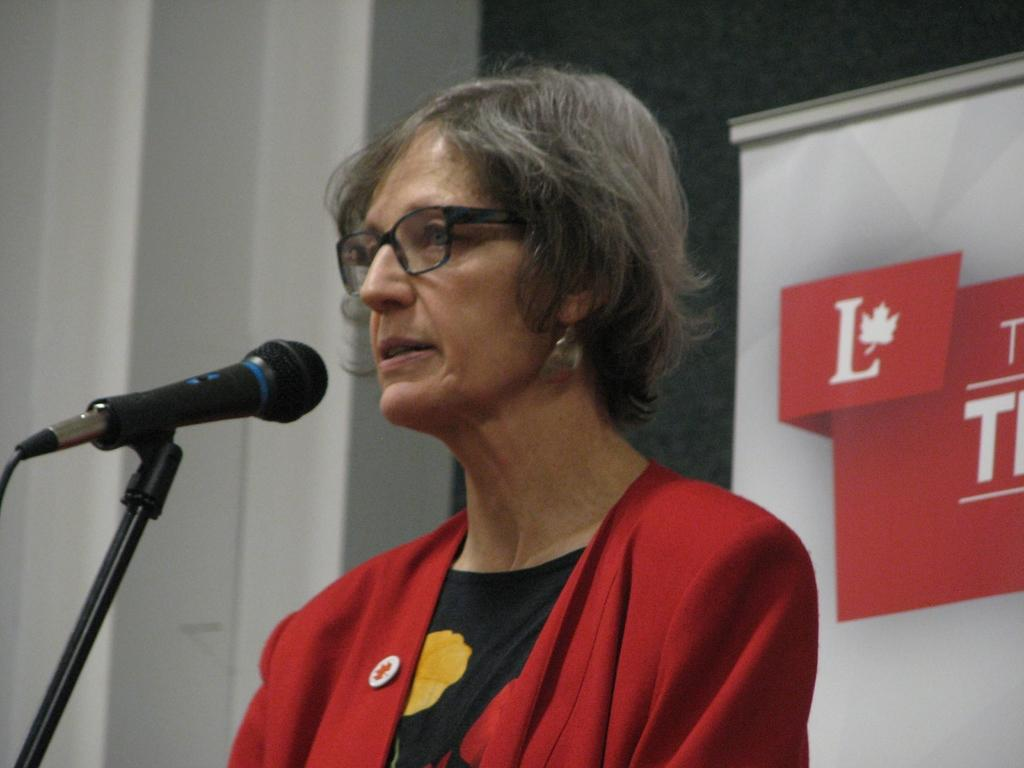Who is the main subject in the image? There is a woman in the image. What is the woman wearing? The woman is wearing glasses. What is the woman holding in the image? The woman is holding a microphone. What can be seen behind the woman in the image? There are papers with text visible behind her. What type of flag is being waved in the image? There is no flag present in the image. What historical event is being discussed in the image? The image does not depict any specific historical event. 